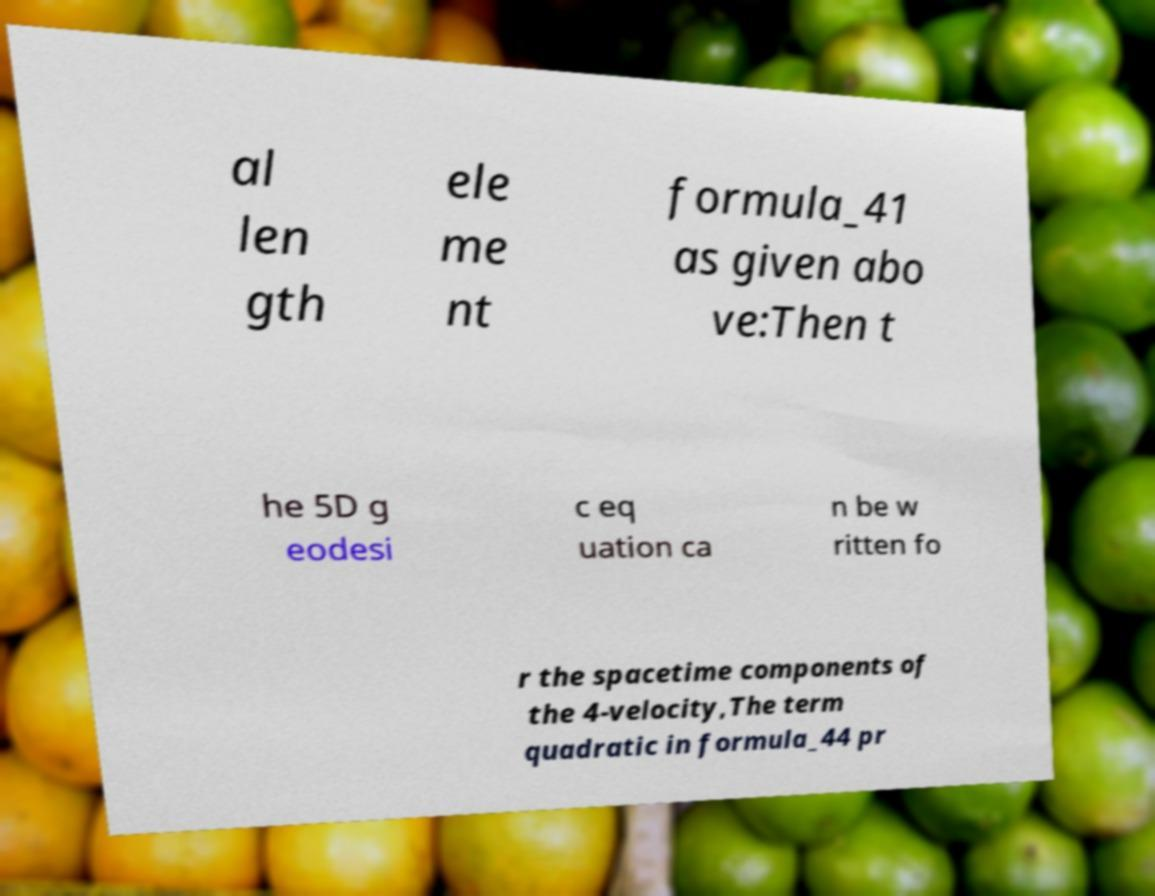Can you read and provide the text displayed in the image?This photo seems to have some interesting text. Can you extract and type it out for me? al len gth ele me nt formula_41 as given abo ve:Then t he 5D g eodesi c eq uation ca n be w ritten fo r the spacetime components of the 4-velocity,The term quadratic in formula_44 pr 